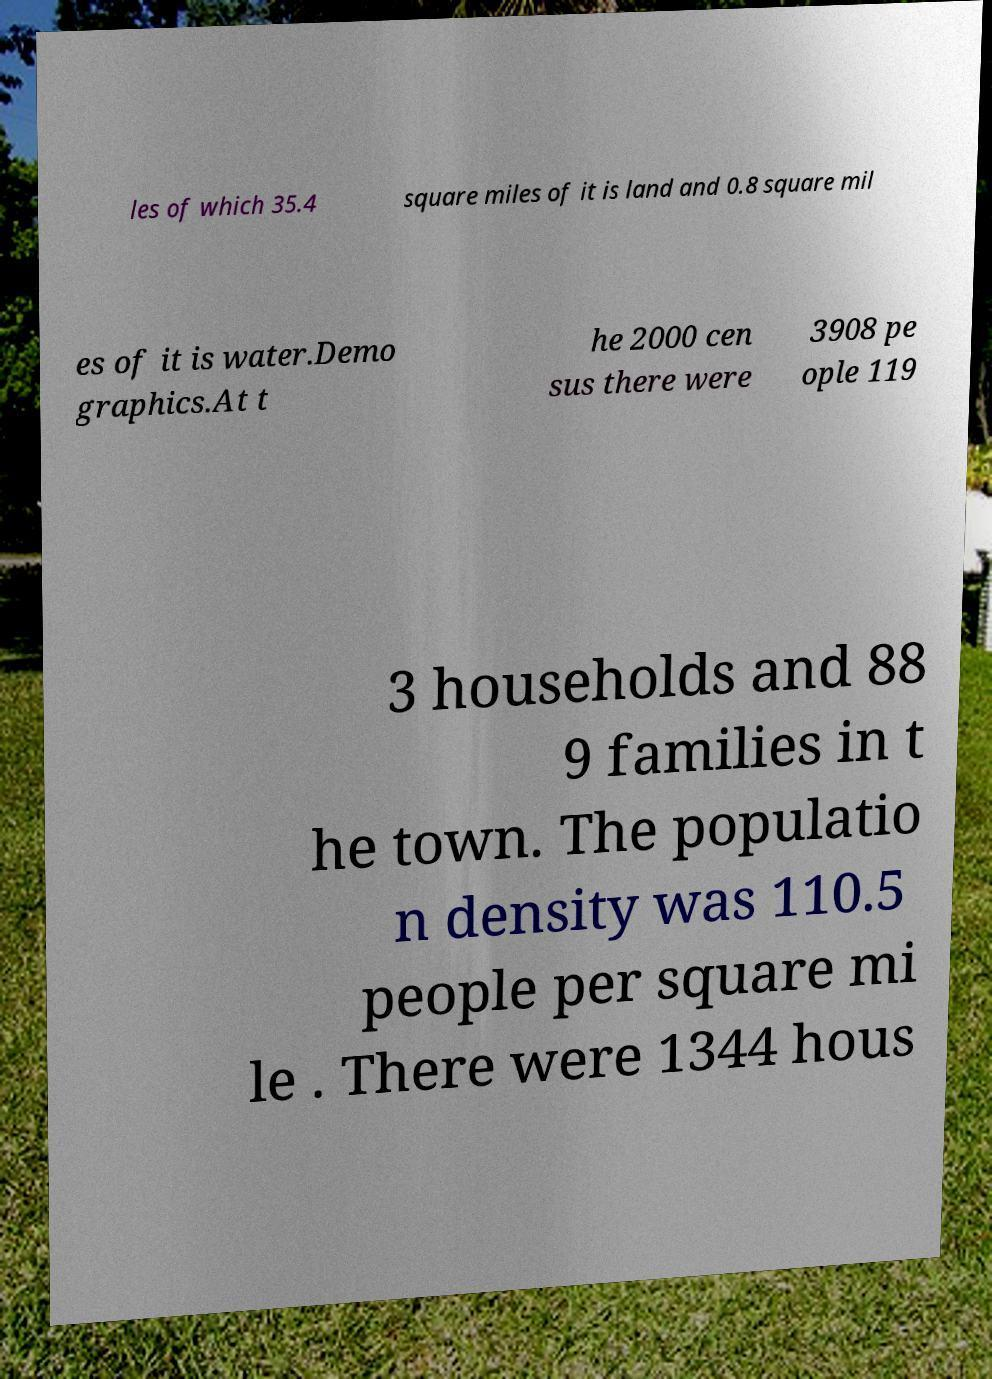Could you extract and type out the text from this image? les of which 35.4 square miles of it is land and 0.8 square mil es of it is water.Demo graphics.At t he 2000 cen sus there were 3908 pe ople 119 3 households and 88 9 families in t he town. The populatio n density was 110.5 people per square mi le . There were 1344 hous 